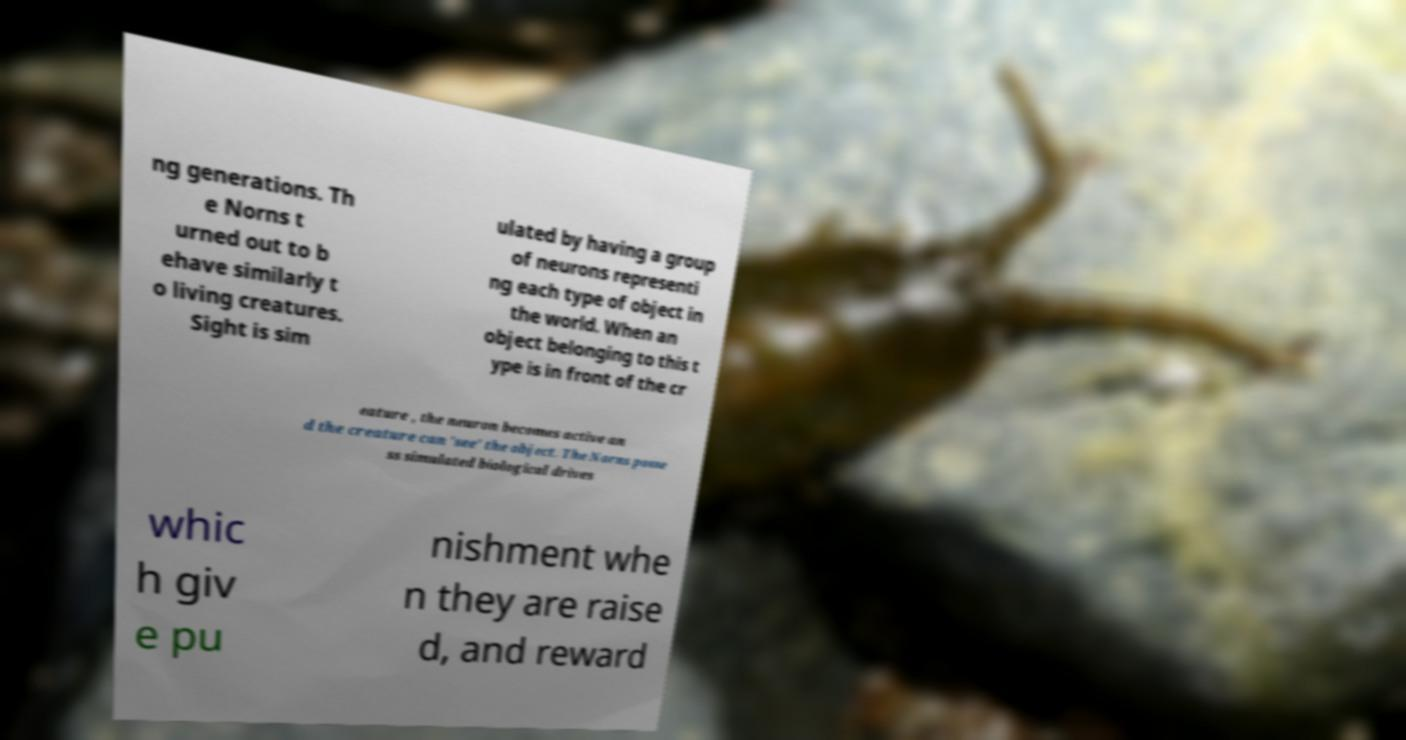Could you extract and type out the text from this image? ng generations. Th e Norns t urned out to b ehave similarly t o living creatures. Sight is sim ulated by having a group of neurons representi ng each type of object in the world. When an object belonging to this t ype is in front of the cr eature , the neuron becomes active an d the creature can 'see' the object. The Norns posse ss simulated biological drives whic h giv e pu nishment whe n they are raise d, and reward 